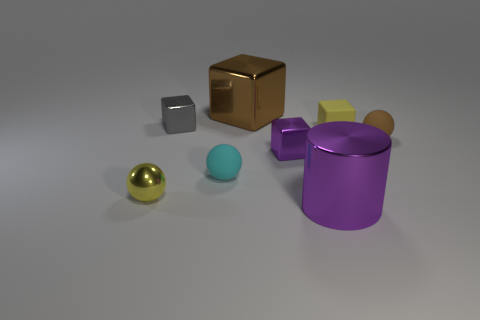Are there any patterns or textures on the objects? The surfaces of the objects are largely smooth and devoid of any intricate patterns or textures, which gives them a minimalist and clean appearance. 